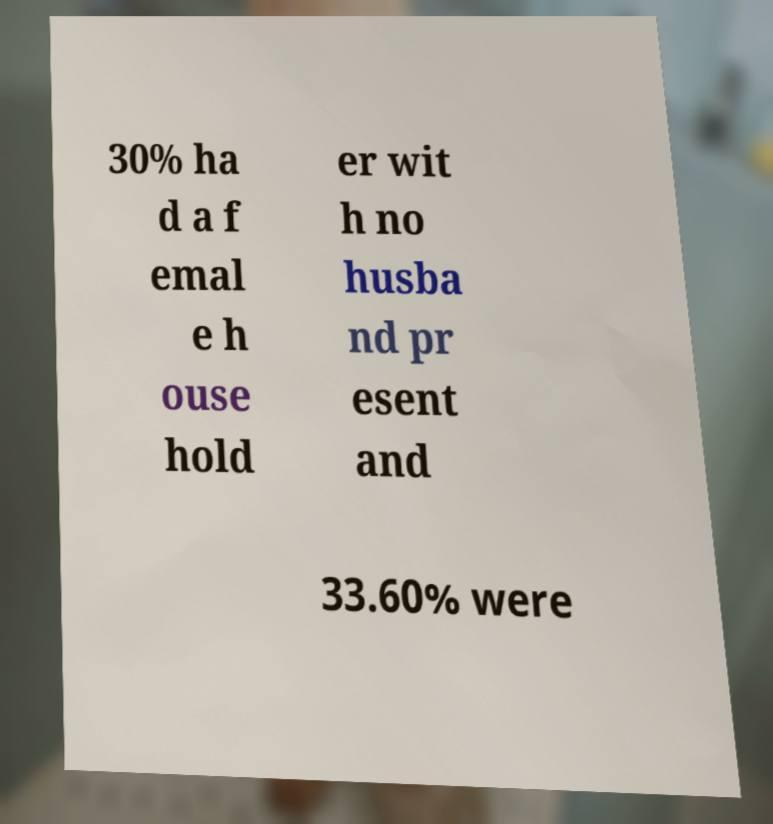For documentation purposes, I need the text within this image transcribed. Could you provide that? 30% ha d a f emal e h ouse hold er wit h no husba nd pr esent and 33.60% were 